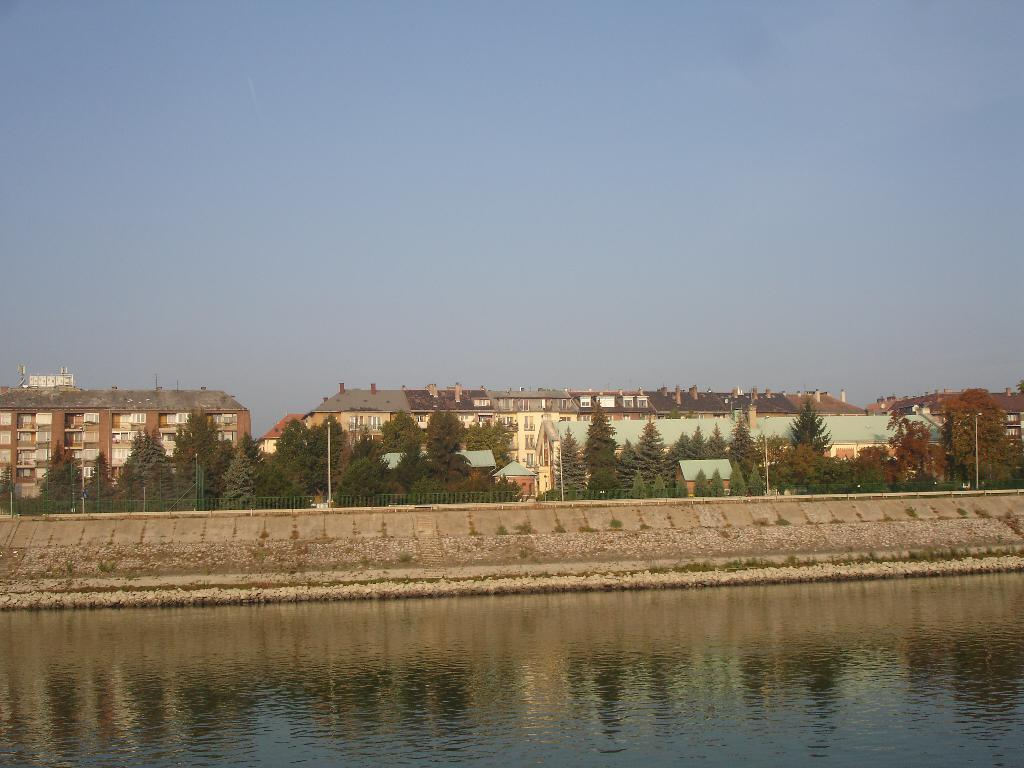What is visible in the image? Water, poles, trees, buildings, and the sky are visible in the image. Can you describe the poles in the image? There are poles in the image, but their specific purpose or appearance cannot be determined from the provided facts. What is the condition of the sky in the image? The sky is clear and visible in the background of the image. What type of vegetation can be seen in the image? Trees are visible in the background of the image. What is the title of the discovery made by the person in the image? There is no person or discovery present in the image; it features water, poles, trees, buildings, and the sky. 